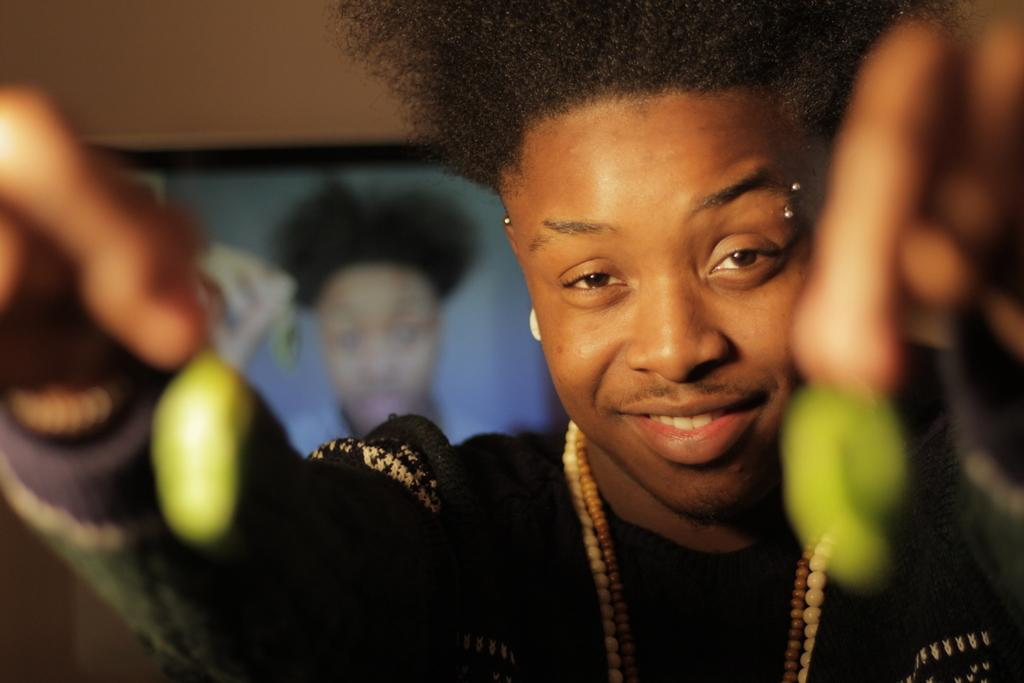Who is present in the image? There is a man in the image. What is the man holding in the image? The man is holding green objects. What can be seen in the background of the image? There is a frame on a wall in the background of the image. What thrill does the man experience while walking down the street with a stranger in the image? There is no indication of the man experiencing any thrill, walking down the street, or interacting with a stranger in the image. 